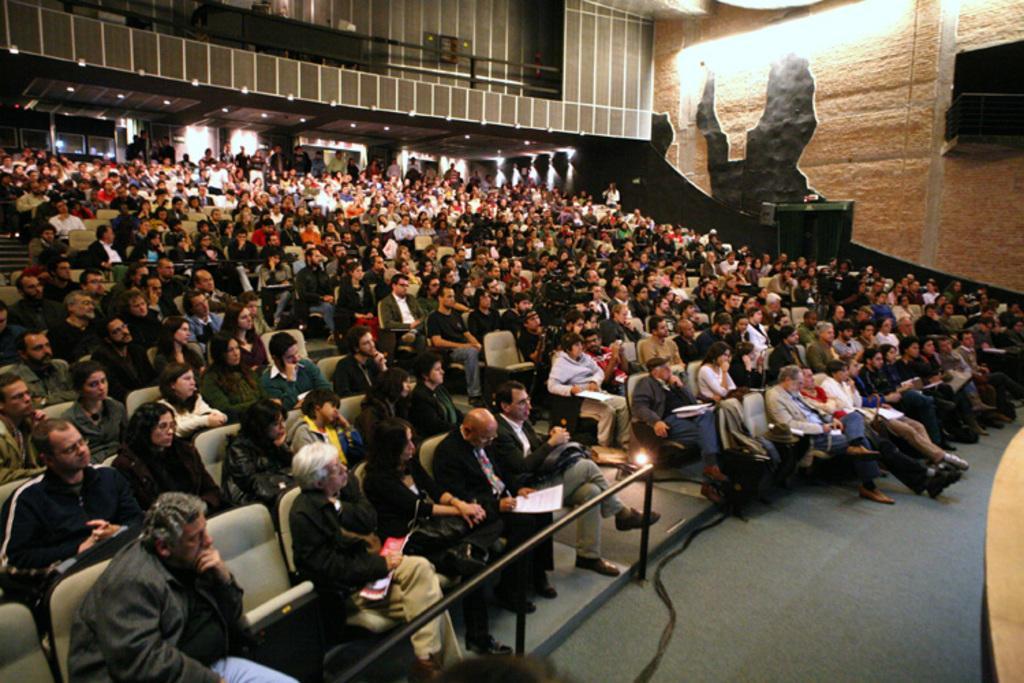Can you describe this image briefly? In this image I can see group of people sitting, the person in front wearing black color blazer holding a pen and paper. Background I can see few persons standing, wall in brown color and I can see few lights. 